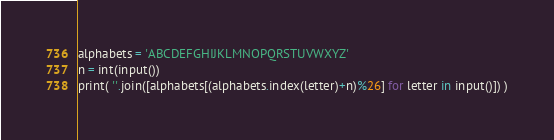<code> <loc_0><loc_0><loc_500><loc_500><_Python_>alphabets = 'ABCDEFGHIJKLMNOPQRSTUVWXYZ'
n = int(input())
print( ''.join([alphabets[(alphabets.index(letter)+n)%26] for letter in input()]) )</code> 